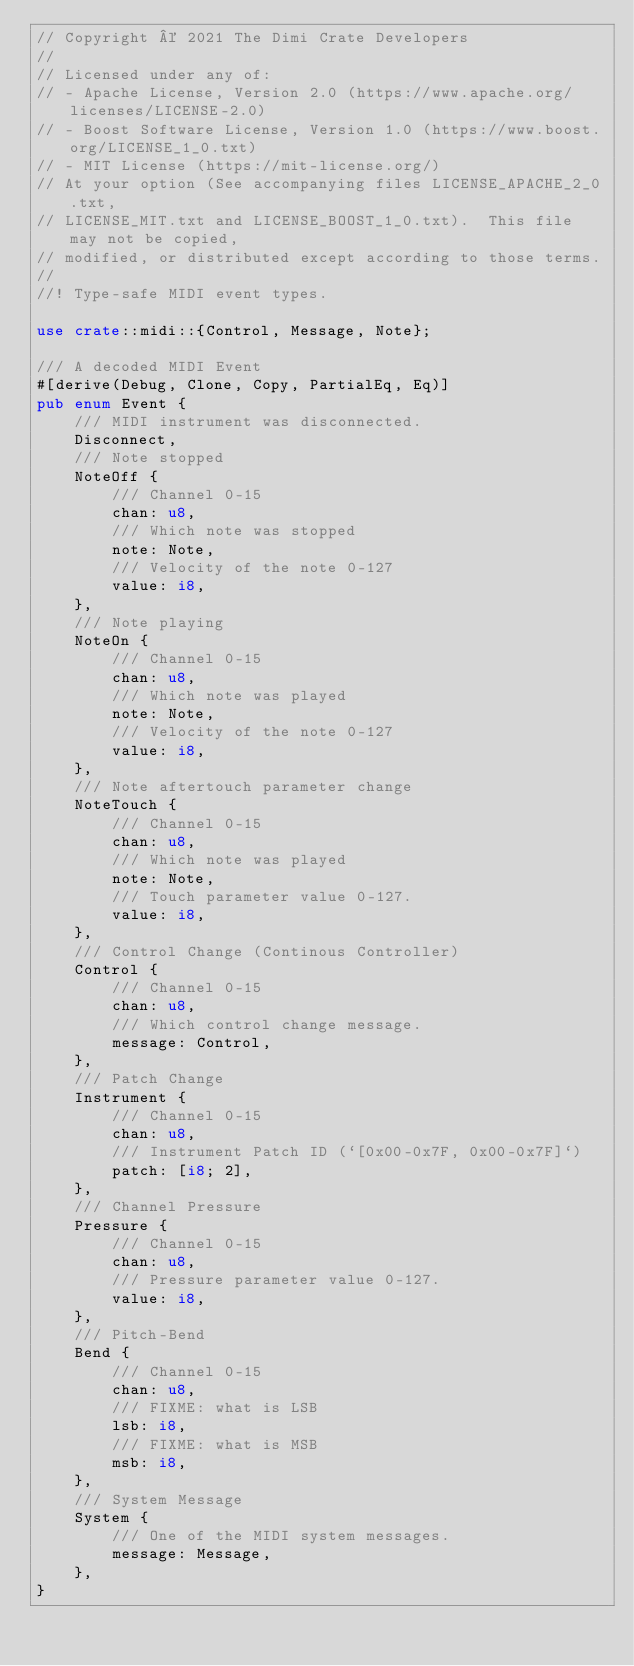Convert code to text. <code><loc_0><loc_0><loc_500><loc_500><_Rust_>// Copyright © 2021 The Dimi Crate Developers
//
// Licensed under any of:
// - Apache License, Version 2.0 (https://www.apache.org/licenses/LICENSE-2.0)
// - Boost Software License, Version 1.0 (https://www.boost.org/LICENSE_1_0.txt)
// - MIT License (https://mit-license.org/)
// At your option (See accompanying files LICENSE_APACHE_2_0.txt,
// LICENSE_MIT.txt and LICENSE_BOOST_1_0.txt).  This file may not be copied,
// modified, or distributed except according to those terms.
//
//! Type-safe MIDI event types.

use crate::midi::{Control, Message, Note};

/// A decoded MIDI Event
#[derive(Debug, Clone, Copy, PartialEq, Eq)]
pub enum Event {
    /// MIDI instrument was disconnected.
    Disconnect,
    /// Note stopped
    NoteOff {
        /// Channel 0-15
        chan: u8,
        /// Which note was stopped
        note: Note,
        /// Velocity of the note 0-127
        value: i8,
    },
    /// Note playing
    NoteOn {
        /// Channel 0-15
        chan: u8,
        /// Which note was played
        note: Note,
        /// Velocity of the note 0-127
        value: i8,
    },
    /// Note aftertouch parameter change
    NoteTouch {
        /// Channel 0-15
        chan: u8,
        /// Which note was played
        note: Note,
        /// Touch parameter value 0-127.
        value: i8,
    },
    /// Control Change (Continous Controller)
    Control {
        /// Channel 0-15
        chan: u8,
        /// Which control change message.
        message: Control,
    },
    /// Patch Change
    Instrument {
        /// Channel 0-15
        chan: u8,
        /// Instrument Patch ID (`[0x00-0x7F, 0x00-0x7F]`)
        patch: [i8; 2],
    },
    /// Channel Pressure
    Pressure {
        /// Channel 0-15
        chan: u8,
        /// Pressure parameter value 0-127.
        value: i8,
    },
    /// Pitch-Bend
    Bend {
        /// Channel 0-15
        chan: u8,
        /// FIXME: what is LSB
        lsb: i8,
        /// FIXME: what is MSB
        msb: i8,
    },
    /// System Message
    System {
        /// One of the MIDI system messages.
        message: Message,
    },
}
</code> 